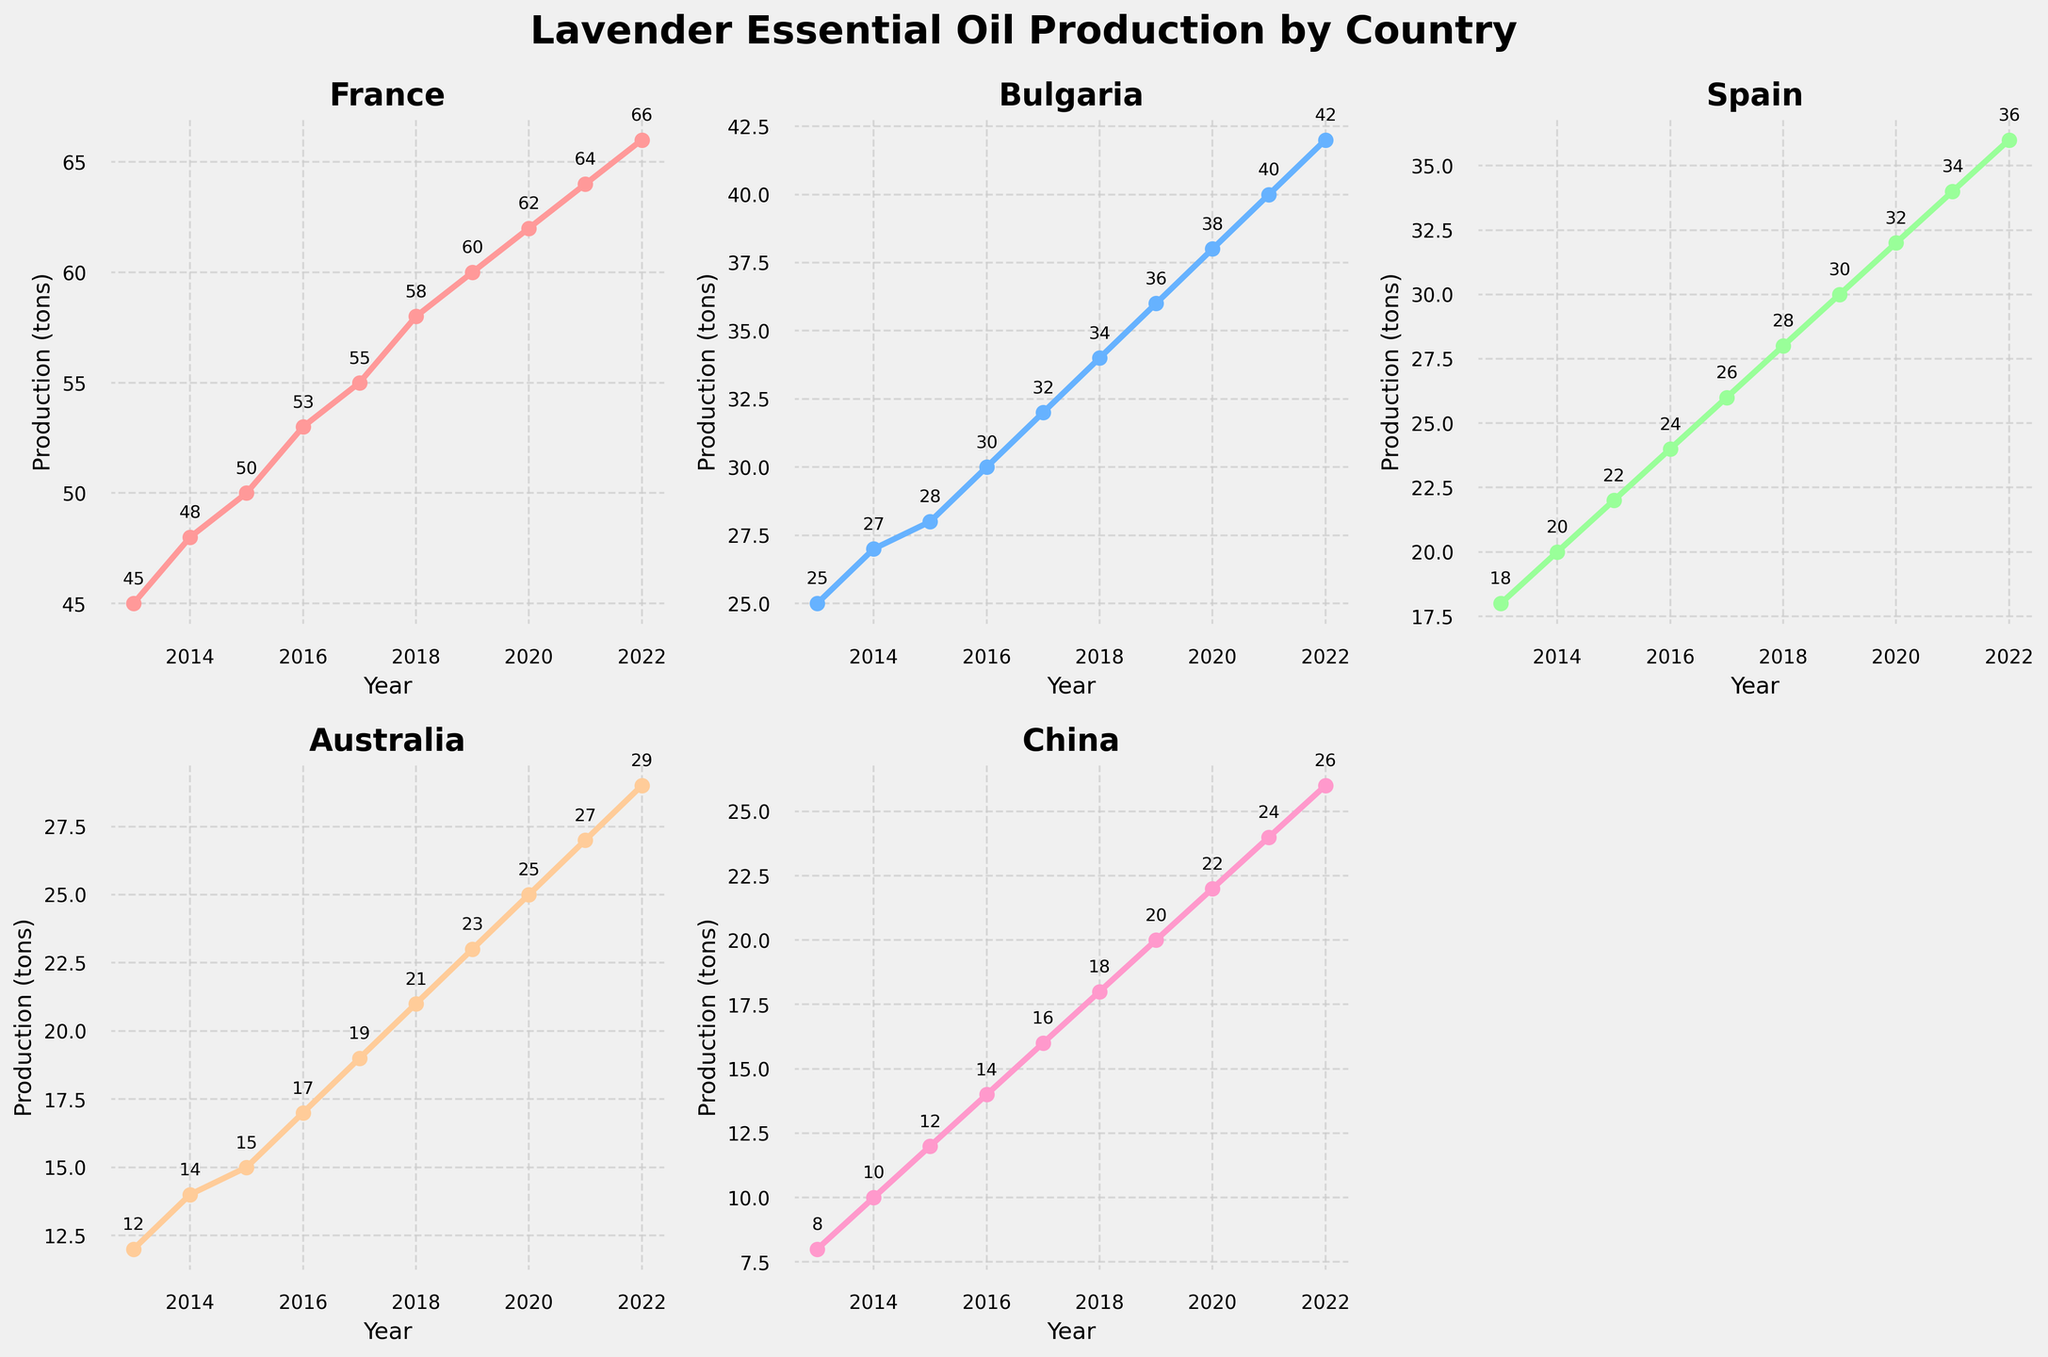What is the title of the figure? The title of the figure is displayed at the top center and usually provides a summary of the graph's content. In this case, it gives an overview of the subject.
Answer: Lavender Essential Oil Production by Country Which country had the highest production of lavender essential oil in 2013? To find this, look at the production levels of all the countries in 2013 and see which is the highest. France's production level for 2013 is the highest among all.
Answer: France How did Bulgaria's production change from 2014 to 2019? Identify Bulgaria's production levels for 2014 and 2019, then find the difference. Bulgaria's production was 27 tons in 2014 and increased to 36 tons in 2019. The change is 36 - 27 = 9 tons.
Answer: Increased by 9 tons By what percentage did China's production increase from 2015 to 2022? First, find China's production in 2015 and 2022. China's production was 12 tons in 2015 and 26 tons in 2022. The percentage increase is calculated by (26-12)/12*100, which is (14/12)*100 = 116.67%.
Answer: 116.67% Which country had a production level closer to Bulgaria's in 2018: Spain or Australia? Look at Bulgaria's production in 2018, which is 34 tons. Then, compare Spain's (28 tons) and Australia's (21 tons) production in the same year. Bulgaria (34 tons) is closer to Spain's (28 tons) than Australia's (21 tons).
Answer: Spain How many data points are depicted for each country over the decade? Observe the number of years listed on the x-axis. Each country's production is plotted for the years 2013 to 2022, giving 10 data points for each country.
Answer: 10 Which country showed the smallest increase in production from 2017 to 2020? Calculate the increase for each country between these years. For France: 62 - 55 = 7, Bulgaria: 38 - 32 = 6, Spain: 32 - 26 = 6, Australia: 25 - 19 = 6, China: 22 - 16 = 6. The smallest increase is shared by Bulgaria, Spain, Australia, and China, each increasing by 6 tons.
Answer: Bulgaria, Spain, Australia, China Among the plotted countries, which had the steepest increase in production between 2015 and 2016? Compare the difference in production levels for each country from 2015 to 2016 and see which is the highest. France shows the steepest increase: 53 - 50 = 3 tons.
Answer: France 